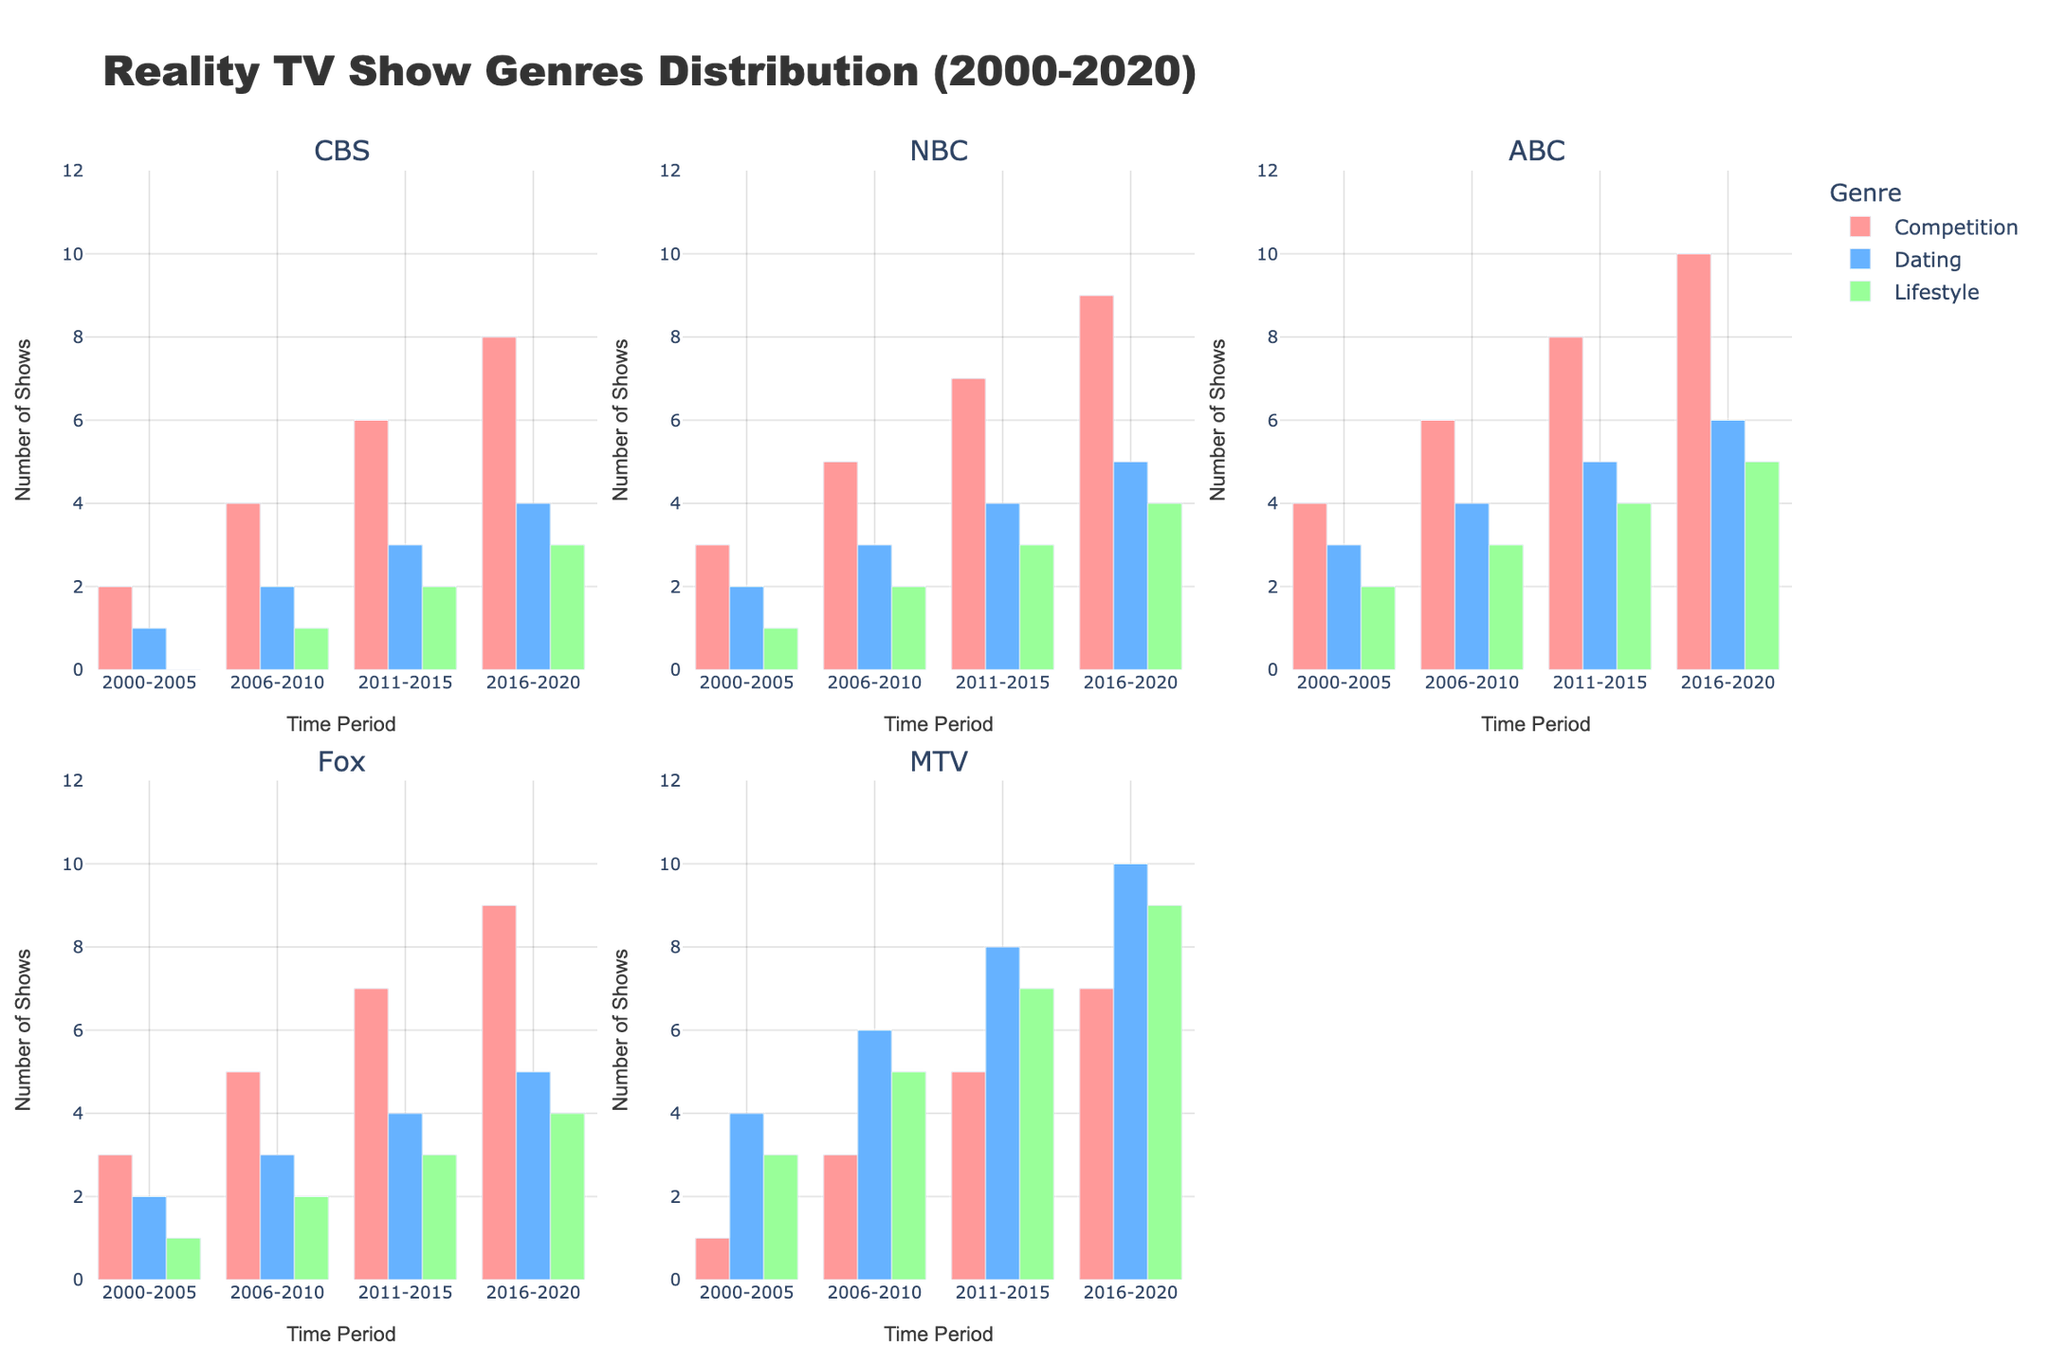Which network had the highest number of competition reality TV shows in the period 2016-2020? Look at the 'Competition' genre bars for the period 2016-2020 across all network subplots. ABC has the highest bar with a count of 10.
Answer: ABC How many dating reality TV shows were aired by MTV in the period 2011-2015? Focus on the bar corresponding to 'Dating' genre in MTV's subplot during 2011-2015. The bar's height represents 8 shows.
Answer: 8 Which time period saw the most growth in dating reality TV shows for CBS? Compare bars for the 'Dating' genre in CBS subplot across successive time periods. The largest increase occurs between 2000-2005 (1) and 2006-2010 (2), a growth of 1.
Answer: 2006-2010 For Fox, which genre had the smallest change in the number of reality TV shows from 2000-2005 to 2016-2020? Evaluate the change for each genre by subtracting the 2000-2005 bar height from the 2016-2020 bar height in Fox subplot. 'Lifestyle' shows the smallest change (increment from 1 to 4, a change of 3).
Answer: Lifestyle Between NBC and CBS, which network aired more competition reality TV shows from 2006-2010? Compare the 'Competition' bars for NBC and CBS during 2006-2010. NBC's bar shows 5, which is more than CBS's bar showing 4.
Answer: NBC How many total lifestyle reality TV shows were aired across all networks in 2011-2015? Sum the heights of 'Lifestyle' genre bars for all networks during 2011-2015. CBS (2) + NBC (3) + ABC (4) + Fox (3) + MTV (7) = 19 shows.
Answer: 19 Which network had the smallest increase in the number of lifestyle reality TV shows from 2000-2005 to 2016-2020? Assess the increment for each network's 'Lifestyle' genre by comparing 2000-2005 to 2016-2020 bars. CBS shows an increase from 0 to 3 (change of 3), which is the smallest among all networks.
Answer: CBS What is the average number of competition reality TV shows aired by ABC across all time periods? Calculate the mean of ABC's 'Competition' show counts: (4+6+8+10)/4 = 7 shows.
Answer: 7 Considering both NBC and Fox, how many more dating reality TV shows did NBC air in 2011-2015 compared to Fox? Subtract Fox's 'Dating' shows in 2011-2015 (4) from NBC's during the same period (4). The difference is 0, so NBC did not air more shows.
Answer: 0 Which genre had the highest overall count of reality TV shows aired by CBS in 2016-2020? Check the height of each genre bar in CBS subplot for 2016-2020. 'Competition' genre has the highest bar with 8 shows.
Answer: Competition 